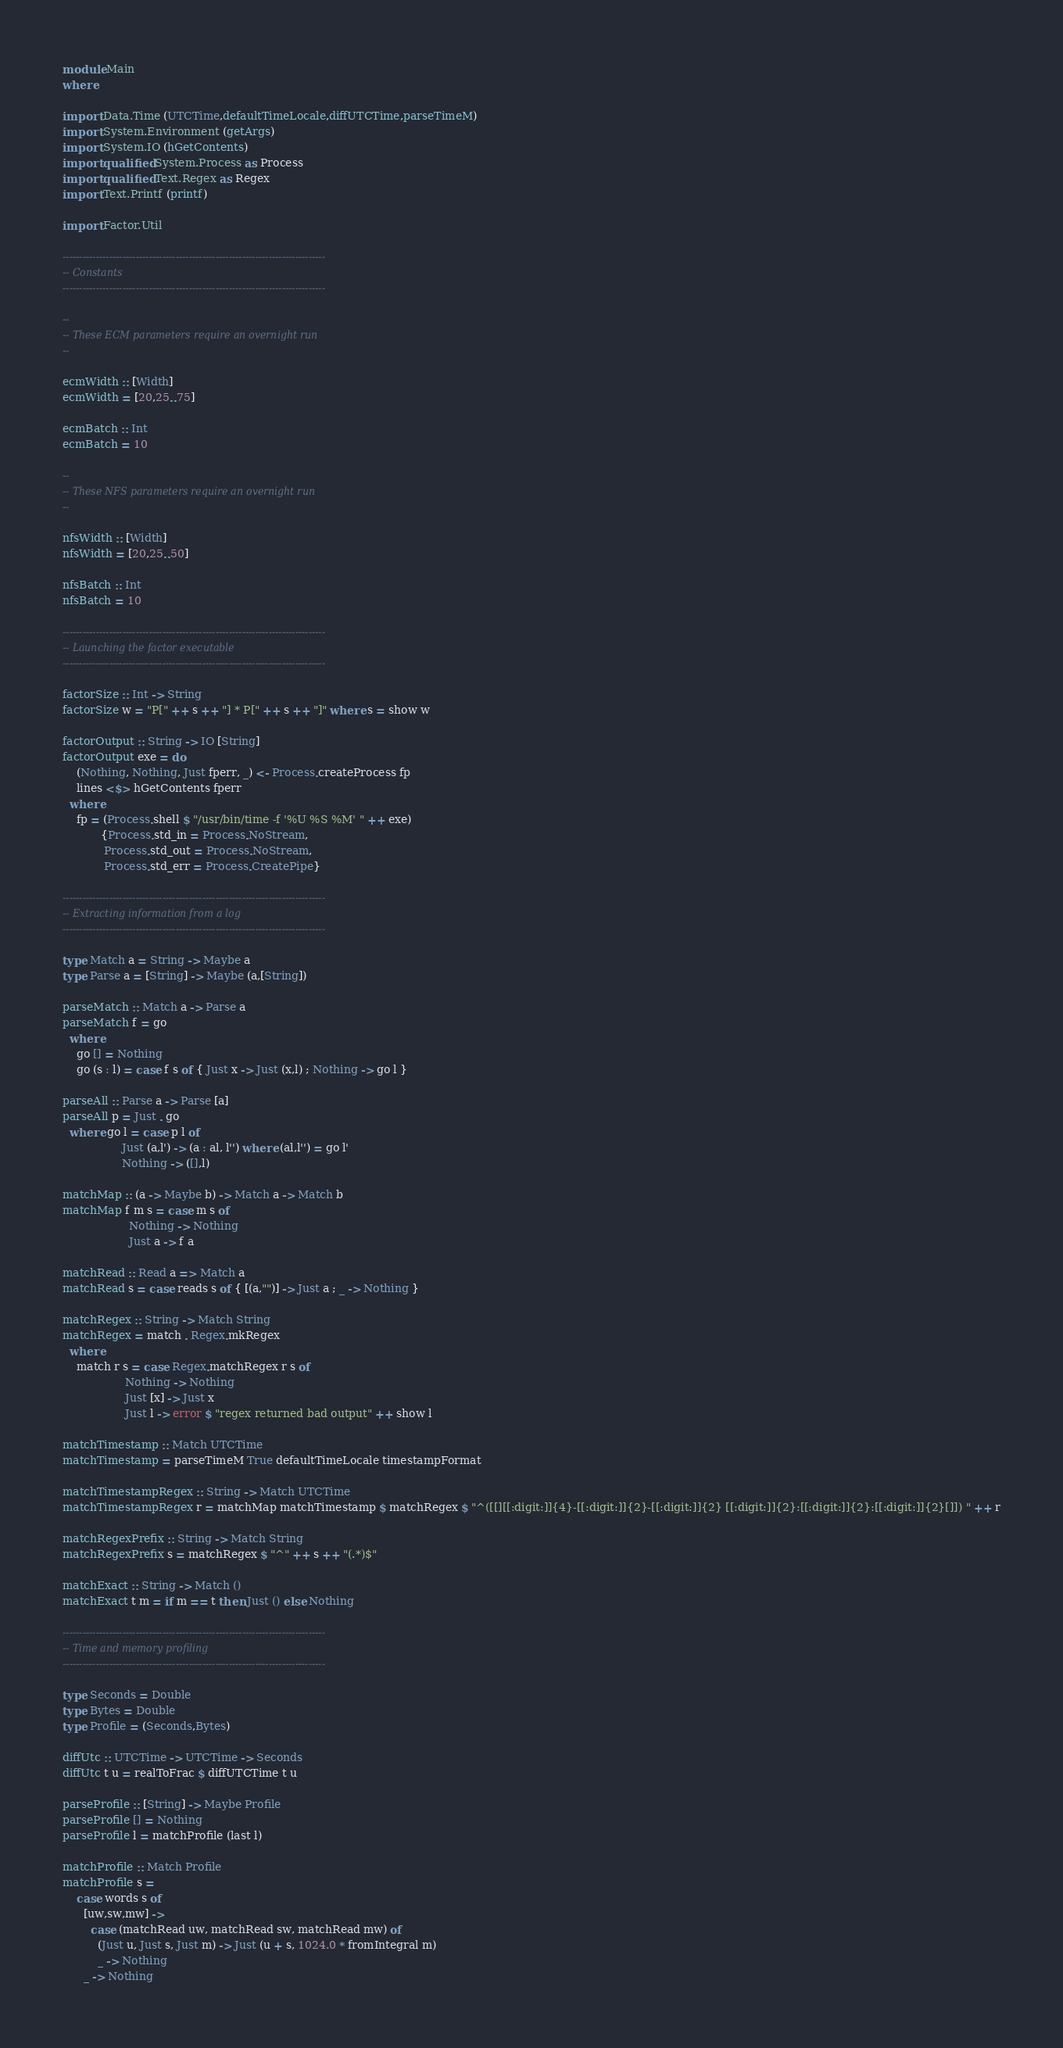Convert code to text. <code><loc_0><loc_0><loc_500><loc_500><_Haskell_>module Main
where

import Data.Time (UTCTime,defaultTimeLocale,diffUTCTime,parseTimeM)
import System.Environment (getArgs)
import System.IO (hGetContents)
import qualified System.Process as Process
import qualified Text.Regex as Regex
import Text.Printf (printf)

import Factor.Util

-------------------------------------------------------------------------------
-- Constants
-------------------------------------------------------------------------------

--
-- These ECM parameters require an overnight run
--

ecmWidth :: [Width]
ecmWidth = [20,25..75]

ecmBatch :: Int
ecmBatch = 10

--
-- These NFS parameters require an overnight run
--

nfsWidth :: [Width]
nfsWidth = [20,25..50]

nfsBatch :: Int
nfsBatch = 10

-------------------------------------------------------------------------------
-- Launching the factor executable
-------------------------------------------------------------------------------

factorSize :: Int -> String
factorSize w = "P[" ++ s ++ "] * P[" ++ s ++ "]" where s = show w

factorOutput :: String -> IO [String]
factorOutput exe = do
    (Nothing, Nothing, Just fperr, _) <- Process.createProcess fp
    lines <$> hGetContents fperr
  where
    fp = (Process.shell $ "/usr/bin/time -f '%U %S %M' " ++ exe)
           {Process.std_in = Process.NoStream,
            Process.std_out = Process.NoStream,
            Process.std_err = Process.CreatePipe}

-------------------------------------------------------------------------------
-- Extracting information from a log
-------------------------------------------------------------------------------

type Match a = String -> Maybe a
type Parse a = [String] -> Maybe (a,[String])

parseMatch :: Match a -> Parse a
parseMatch f = go
  where
    go [] = Nothing
    go (s : l) = case f s of { Just x -> Just (x,l) ; Nothing -> go l }

parseAll :: Parse a -> Parse [a]
parseAll p = Just . go
  where go l = case p l of
                 Just (a,l') -> (a : al, l'') where (al,l'') = go l'
                 Nothing -> ([],l)

matchMap :: (a -> Maybe b) -> Match a -> Match b
matchMap f m s = case m s of
                   Nothing -> Nothing
                   Just a -> f a

matchRead :: Read a => Match a
matchRead s = case reads s of { [(a,"")] -> Just a ; _ -> Nothing }

matchRegex :: String -> Match String
matchRegex = match . Regex.mkRegex
  where
    match r s = case Regex.matchRegex r s of
                  Nothing -> Nothing
                  Just [x] -> Just x
                  Just l -> error $ "regex returned bad output" ++ show l

matchTimestamp :: Match UTCTime
matchTimestamp = parseTimeM True defaultTimeLocale timestampFormat

matchTimestampRegex :: String -> Match UTCTime
matchTimestampRegex r = matchMap matchTimestamp $ matchRegex $ "^([[][[:digit:]]{4}-[[:digit:]]{2}-[[:digit:]]{2} [[:digit:]]{2}:[[:digit:]]{2}:[[:digit:]]{2}[]]) " ++ r

matchRegexPrefix :: String -> Match String
matchRegexPrefix s = matchRegex $ "^" ++ s ++ "(.*)$"

matchExact :: String -> Match ()
matchExact t m = if m == t then Just () else Nothing

-------------------------------------------------------------------------------
-- Time and memory profiling
-------------------------------------------------------------------------------

type Seconds = Double
type Bytes = Double
type Profile = (Seconds,Bytes)

diffUtc :: UTCTime -> UTCTime -> Seconds
diffUtc t u = realToFrac $ diffUTCTime t u

parseProfile :: [String] -> Maybe Profile
parseProfile [] = Nothing
parseProfile l = matchProfile (last l)

matchProfile :: Match Profile
matchProfile s =
    case words s of
      [uw,sw,mw] ->
        case (matchRead uw, matchRead sw, matchRead mw) of
          (Just u, Just s, Just m) -> Just (u + s, 1024.0 * fromIntegral m)
          _ -> Nothing
      _ -> Nothing
</code> 